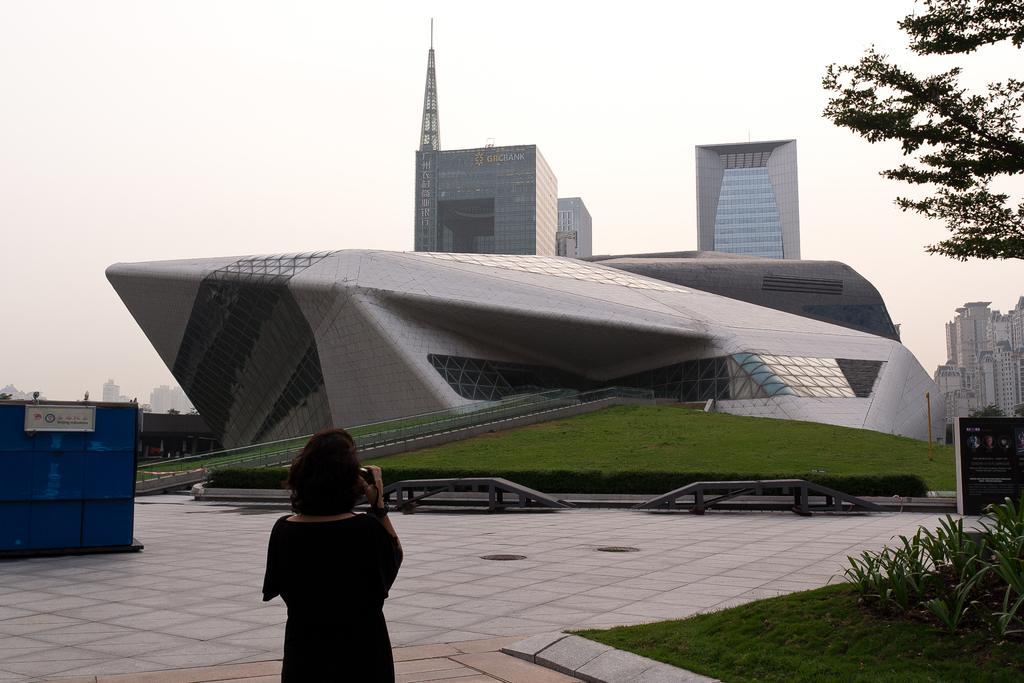Can you describe this image briefly? In the center of the image we can see building and grass. In the background we can see buildings and sky. At the bottom of the image we can see person, ground, grass and plants. 